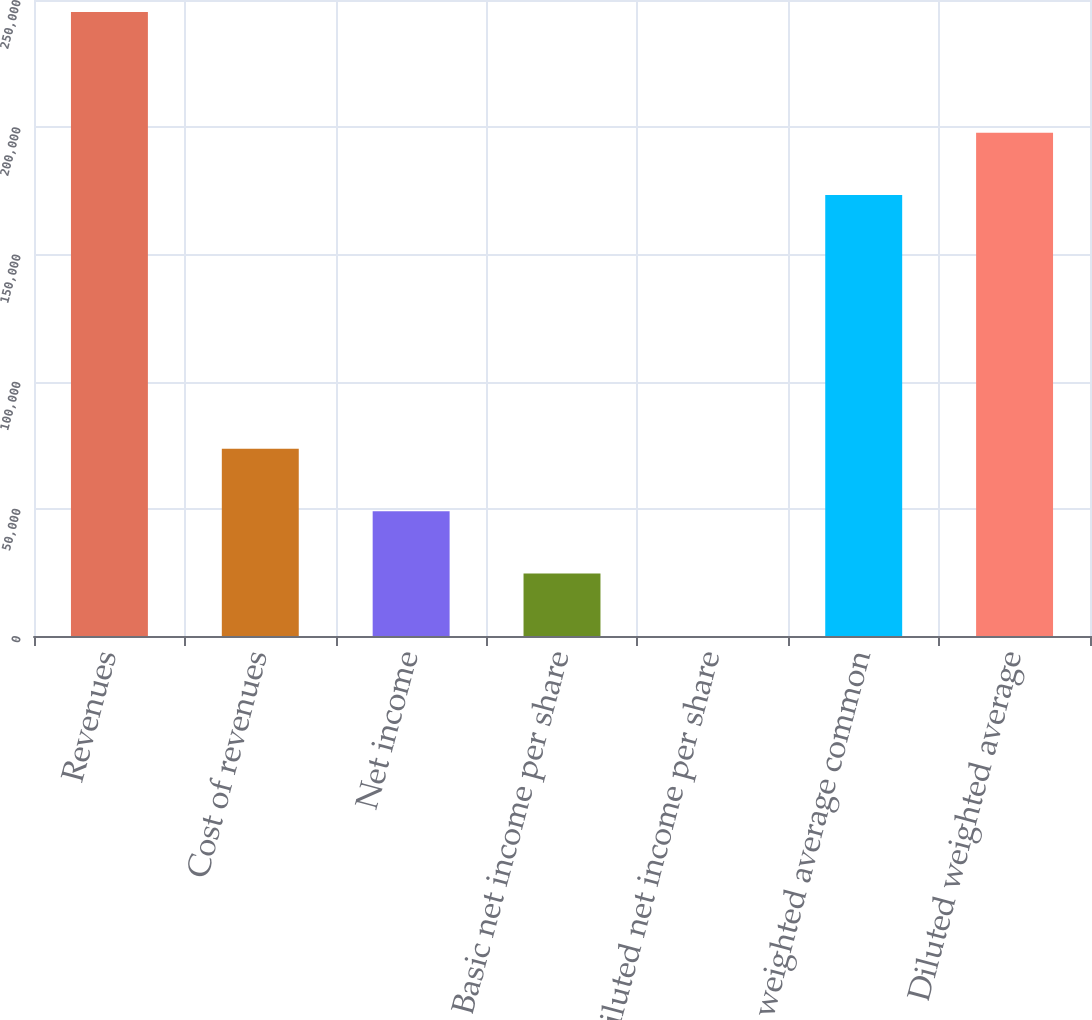Convert chart. <chart><loc_0><loc_0><loc_500><loc_500><bar_chart><fcel>Revenues<fcel>Cost of revenues<fcel>Net income<fcel>Basic net income per share<fcel>Diluted net income per share<fcel>Basic weighted average common<fcel>Diluted weighted average<nl><fcel>245318<fcel>73595.5<fcel>49063.8<fcel>24532<fcel>0.2<fcel>173317<fcel>197849<nl></chart> 